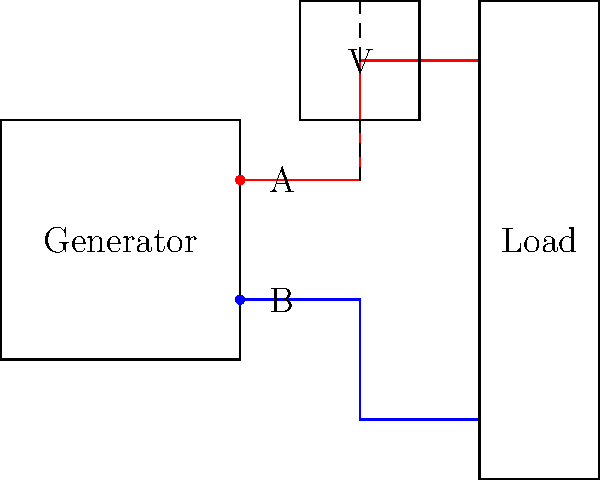As a travel agent organizing a rural retreat, you encounter a power issue with the generator supplying electricity to the guest cabins. Using the provided wiring diagram, which shows a generator connected to a load through two wires (A and B) and a voltmeter connected across the wires, what would be the most likely cause if the voltmeter reads 0V while the generator is running? To troubleshoot this issue, let's follow these steps:

1. Verify the generator is running: The question states the generator is running, so we can rule out generator failure.

2. Check the voltmeter reading: The voltmeter shows 0V, which indicates no potential difference between points A and B.

3. Analyze the circuit:
   a) In a properly functioning circuit, there should be a voltage difference between points A and B when the generator is running.
   b) A 0V reading suggests that either both points have the same potential or there's no connection between the voltmeter and at least one of the wires.

4. Consider possible causes:
   a) Both wires could be disconnected from the generator, resulting in no voltage.
   b) Both wires could be shorted together somewhere along the line, equalizing their potential.
   c) One wire could be disconnected, and the voltmeter is only connected to the other wire.

5. Evaluate the most likely cause:
   Given that this is a rural setting with potentially rough conditions, the most probable cause is a disconnected wire. A complete short circuit or both wires being disconnected is less likely.

6. Conclude:
   The most likely cause is that one of the wires (either A or B) has become disconnected from the generator. This would result in an open circuit, and the voltmeter would read 0V as it's effectively measuring the potential difference between a single point and itself.
Answer: One disconnected wire (A or B) from the generator 